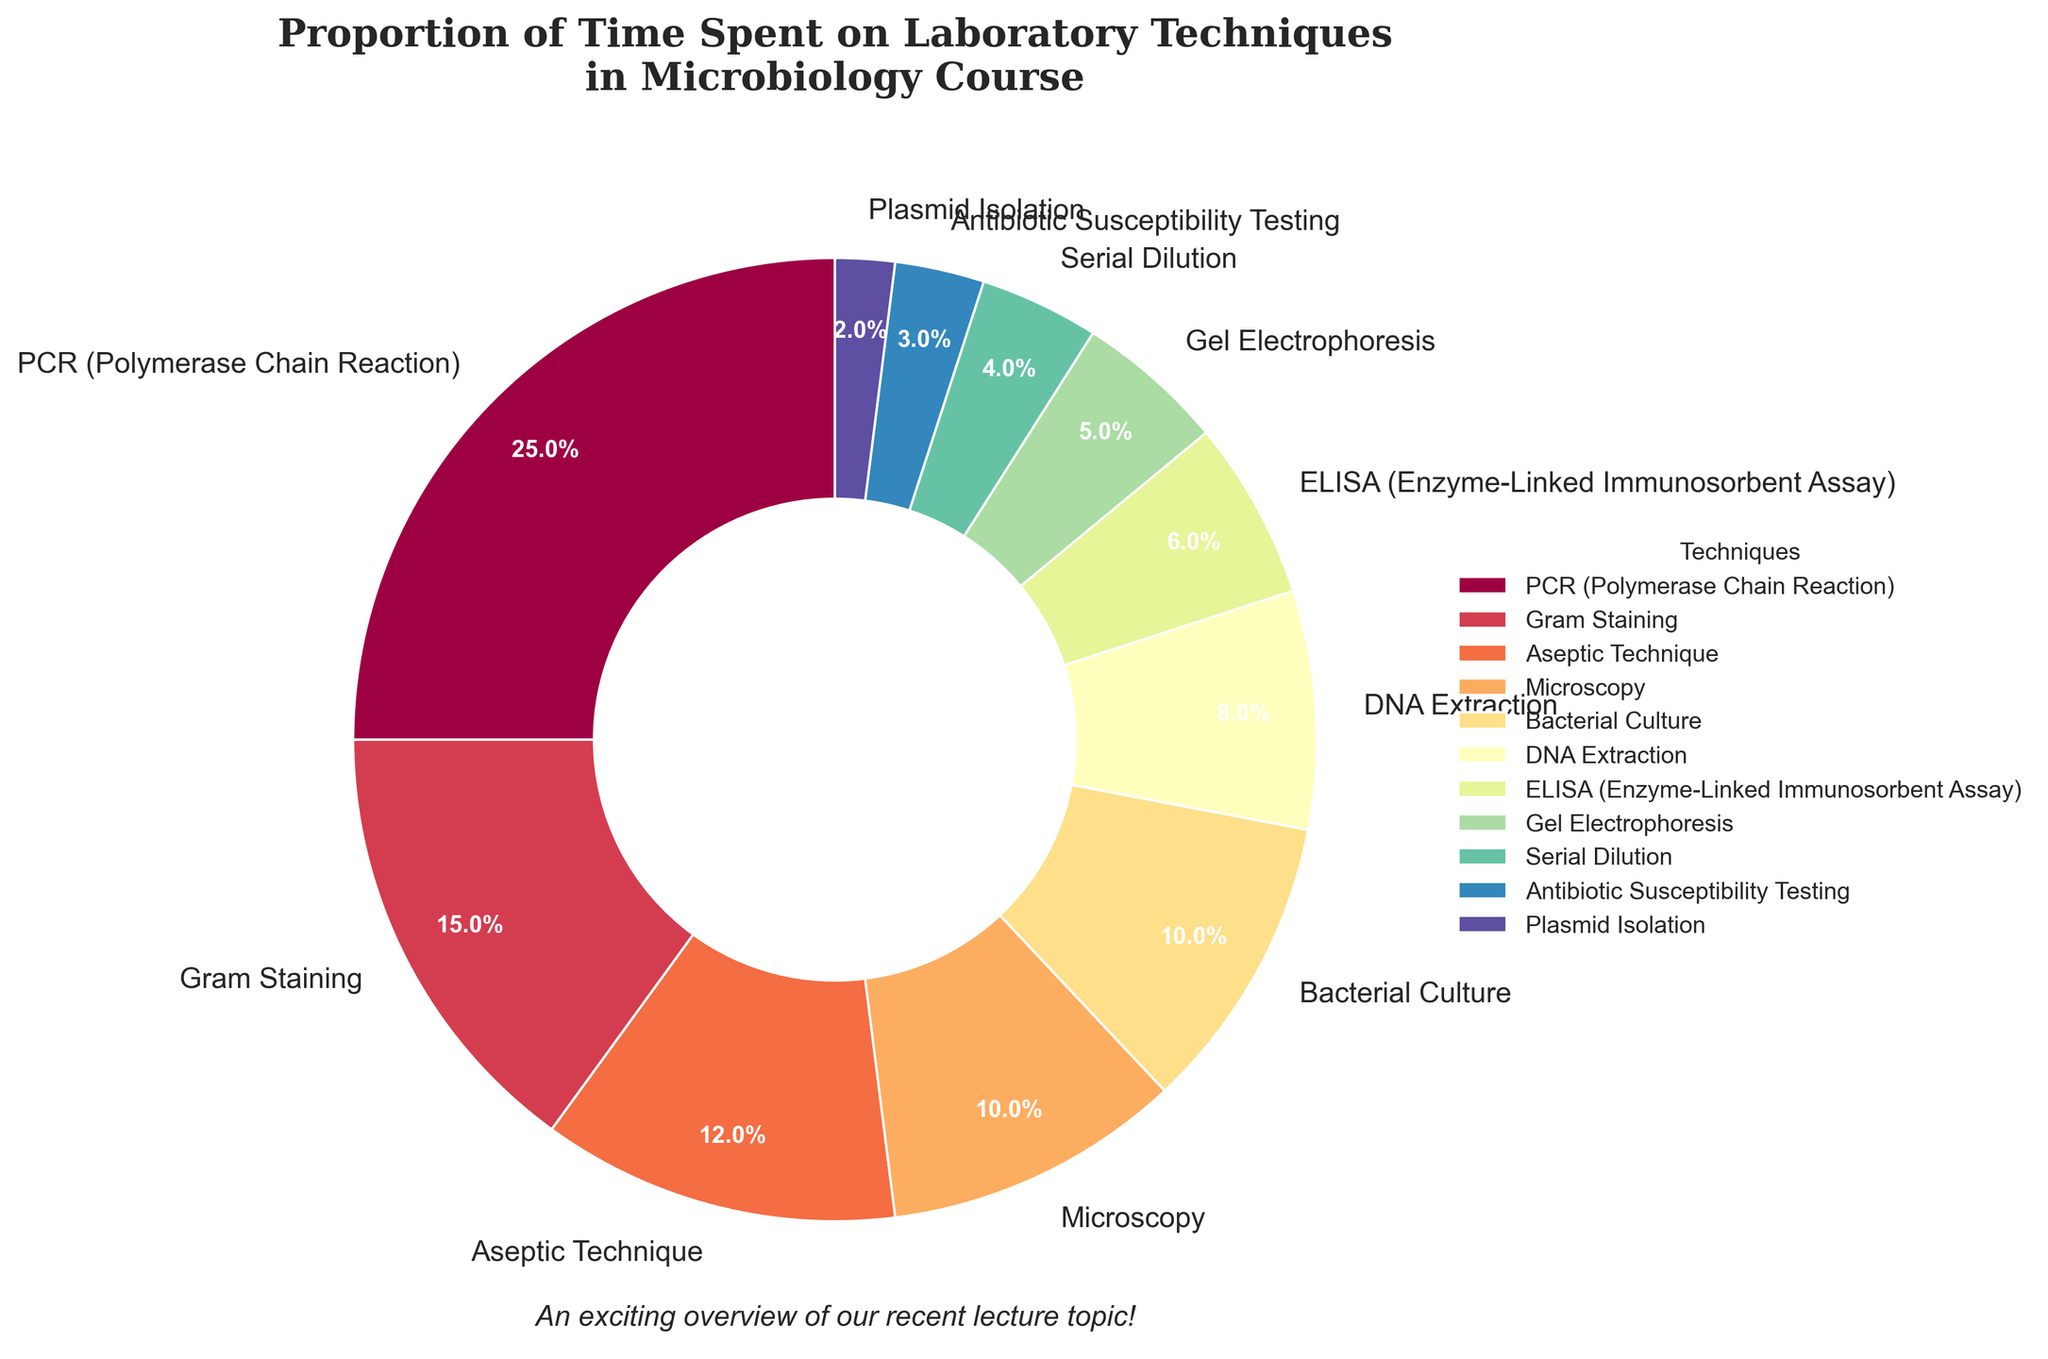What percentage of time is spent on PCR compared to Gram Staining? To determine this, we need to refer to the pie chart. PCR accounts for 25% of the time, while Gram Staining accounts for 15%. Comparatively, 25% is greater than 15%.
Answer: PCR: 25%, Gram Staining: 15% Which technique takes up the least amount of time? By looking at the pie chart, we can see that Plasmid Isolation takes up the smallest portion of the pie chart.
Answer: Plasmid Isolation: 2% What is the combined percentage of time spent on Aseptic Technique and Bacterial Culture? To find the sum, add the percentages for Aseptic Technique and Bacterial Culture. Aseptic Technique is 12% and Bacterial Culture is 10%. Summing them gives 12% + 10% = 22%.
Answer: 22% Rank the techniques from most to least time-consuming. By observing the relative sizes of the slices in the pie chart, the techniques can be ranked as follows: PCR (25%), Gram Staining (15%), Aseptic Technique (12%), Microscopy (10%), Bacterial Culture (10%), DNA Extraction (8%), ELISA (6%), Gel Electrophoresis (5%), Serial Dilution (4%), Antibiotic Susceptibility Testing (3%), and Plasmid Isolation (2%).
Answer: PCR > Gram Staining > Aseptic Technique > Microscopy > Bacterial Culture > DNA Extraction > ELISA > Gel Electrophoresis > Serial Dilution > Antibiotic Susceptibility Testing > Plasmid Isolation How much more time is spent on Microscopy compared to Gel Electrophoresis? To find the difference, subtract the percentage of time spent on Gel Electrophoresis from the time spent on Microscopy. Microscopy accounts for 10% and Gel Electrophoresis for 5%. Thus, 10% - 5% = 5%.
Answer: 5% If the techniques are grouped into molecular techniques (PCR, DNA Extraction, Gel Electrophoresis, Plasmid Isolation) and microbiological techniques (Gram Staining, Aseptic Technique, Microscopy, Bacterial Culture, ELISA, Serial Dilution, Antibiotic Susceptibility Testing), which group takes up more time? Summing the percentages, molecular techniques account for PCR (25%) + DNA Extraction (8%) + Gel Electrophoresis (5%) + Plasmid Isolation (2%) = 40%. Microbiological techniques add up to 15% (Gram Staining) + 12% (Aseptic Technique) + 10% (Microscopy) + 10% (Bacterial Culture) + 6% (ELISA) + 4% (Serial Dilution) + 3% (Antibiotic Susceptibility Testing) = 60%. Therefore, microbiological techniques take up more time.
Answer: Microbiological techniques What visual clues indicate that PCR is the most time-consuming technique? Observing the pie chart, the largest slice belongs to PCR, which indicates it covers the highest percentage at 25%.
Answer: Largest slice: PCR (25%) What is the percentage difference between time spent on ELISA and Serial Dilution? Calculate the difference by subtracting the percentage for Serial Dilution from that of ELISA: 6% (ELISA) - 4% (Serial Dilution) = 2%.
Answer: 2% Which colors are used in the pie chart to represent the top three most time-consuming techniques? The top three techniques (PCR, Gram Staining, Aseptic Technique) are represented by the largest slices. By referring to the visual, observe the colors used for these three.
Answer: PCR: Check the visual for the specific color, Gram Staining: Check the visual for the specific color, Aseptic Technique: Check the visual for the specific color If the time spent on all techniques is increased by 5%, what would be the new percentage for Gram Staining? To find the new percentage, add 5% to the current percentage of Gram Staining: 15% + 5% = 20%.
Answer: 20% 